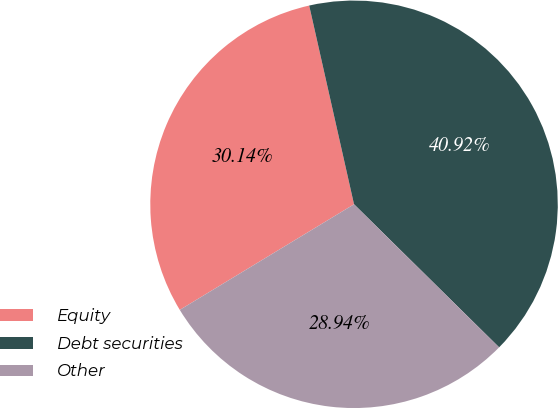<chart> <loc_0><loc_0><loc_500><loc_500><pie_chart><fcel>Equity<fcel>Debt securities<fcel>Other<nl><fcel>30.14%<fcel>40.92%<fcel>28.94%<nl></chart> 